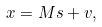Convert formula to latex. <formula><loc_0><loc_0><loc_500><loc_500>x = M s + v ,</formula> 